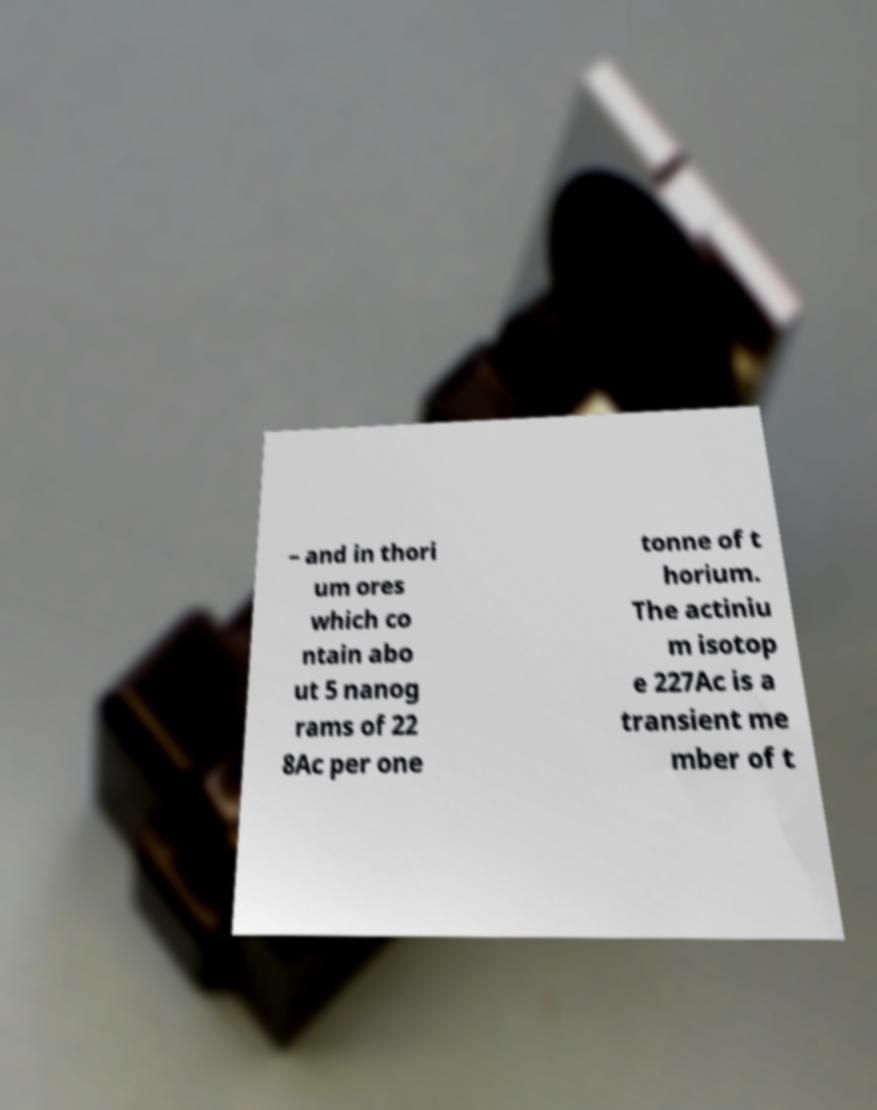Please identify and transcribe the text found in this image. – and in thori um ores which co ntain abo ut 5 nanog rams of 22 8Ac per one tonne of t horium. The actiniu m isotop e 227Ac is a transient me mber of t 